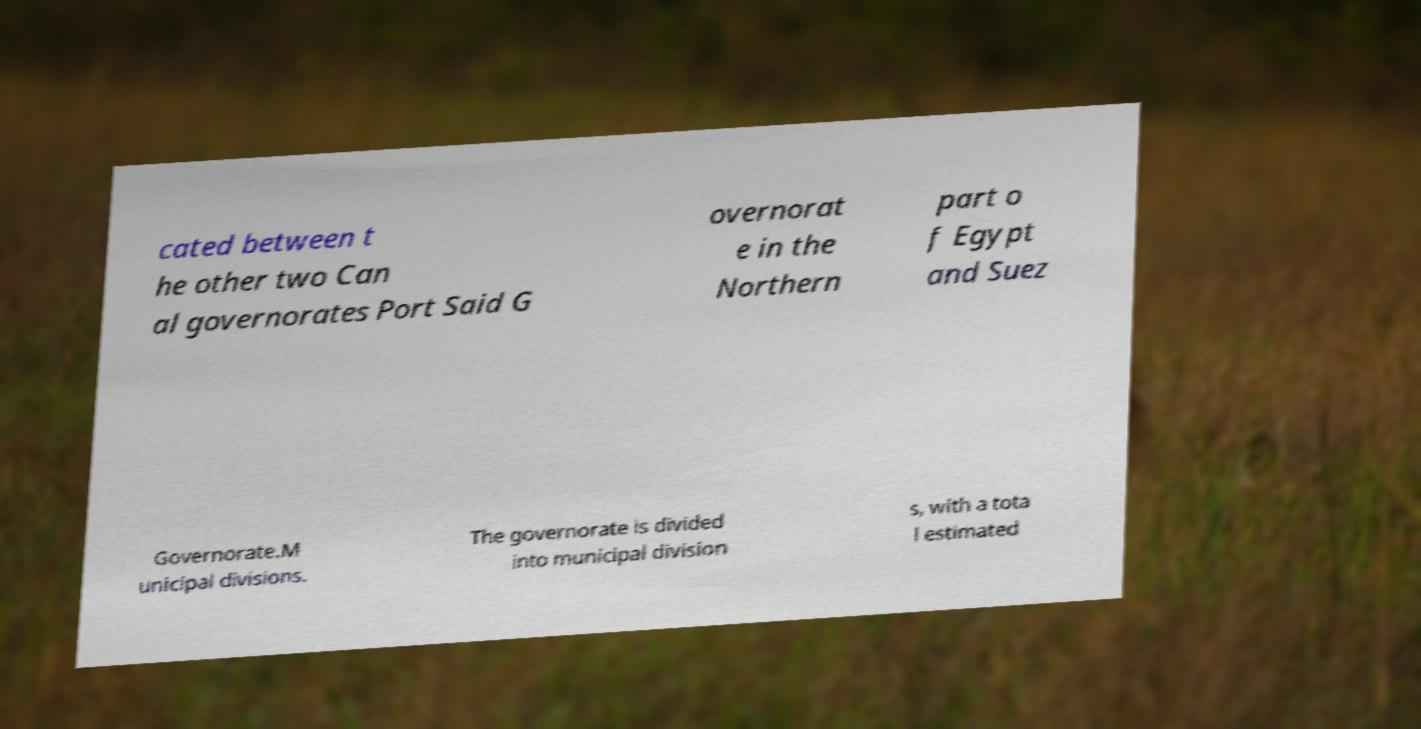Can you read and provide the text displayed in the image?This photo seems to have some interesting text. Can you extract and type it out for me? cated between t he other two Can al governorates Port Said G overnorat e in the Northern part o f Egypt and Suez Governorate.M unicipal divisions. The governorate is divided into municipal division s, with a tota l estimated 